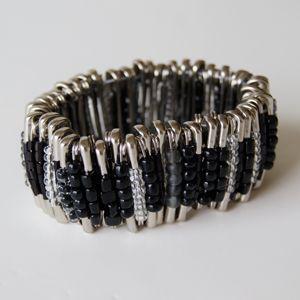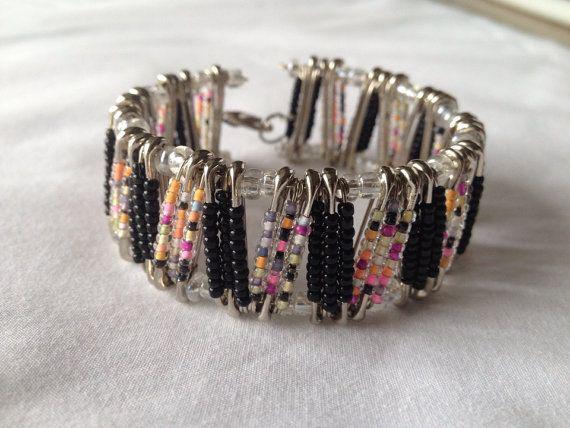The first image is the image on the left, the second image is the image on the right. Given the left and right images, does the statement "The bracelet in the image on the right uses a clasp to close." hold true? Answer yes or no. Yes. The first image is the image on the left, the second image is the image on the right. For the images shown, is this caption "All images are bracelets sitting the same position on a plain, solid colored surface." true? Answer yes or no. Yes. 